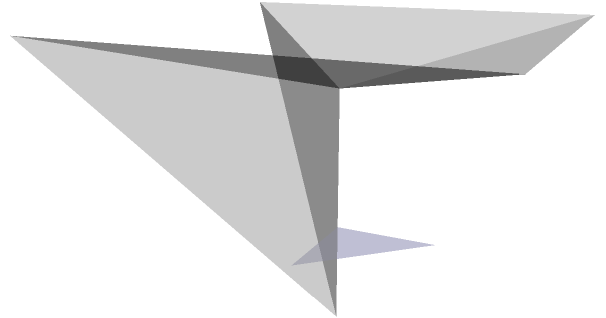Consider a right circular cone with its vertex at the origin and a plane intersecting it as shown in the figure. The plane passes through points $A(0,0,1)$, $B(1,0,1)$, and $C(0,1,1)$. Determine the type of conic section formed by the intersection of the plane and the cone, and provide a brief justification for your answer. To determine the type of conic section, we need to analyze the angle between the plane and the axis of the cone:

1) The axis of the cone is the z-axis (vertical line through the origin).

2) To find the normal vector of the plane:
   $\vec{AB} = (1,0,0)$
   $\vec{AC} = (0,1,0)$
   Normal vector $\vec{n} = \vec{AB} \times \vec{AC} = (0,0,1)$

3) The angle $\theta$ between the plane and the z-axis is the complement of the angle between $\vec{n}$ and the z-axis:
   $\cos \theta = \frac{\vec{n} \cdot (0,0,1)}{|\vec{n}||(0,0,1)|} = 1$

4) This means $\theta = 0°$, so the plane is perpendicular to the axis of the cone.

5) When a plane intersects a cone perpendicular to its axis, the resulting conic section is a circle.

Therefore, the intersection of the plane and the cone forms a circle.
Answer: Circle 